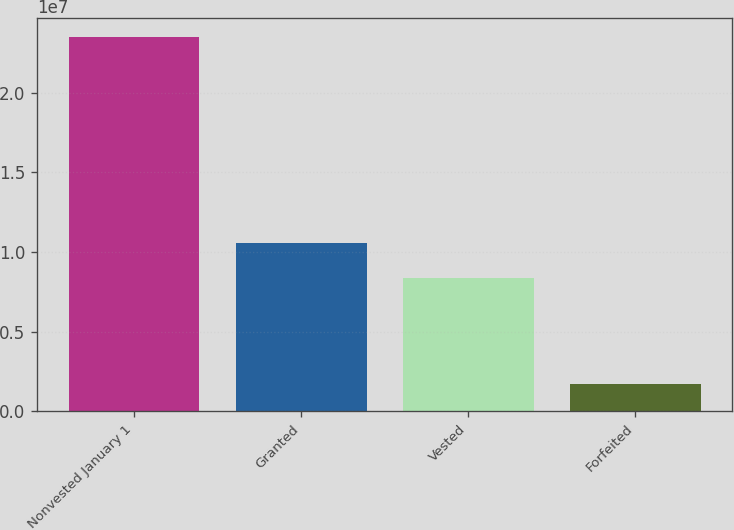<chart> <loc_0><loc_0><loc_500><loc_500><bar_chart><fcel>Nonvested January 1<fcel>Granted<fcel>Vested<fcel>Forfeited<nl><fcel>2.34908e+07<fcel>1.05567e+07<fcel>8.37985e+06<fcel>1.72271e+06<nl></chart> 